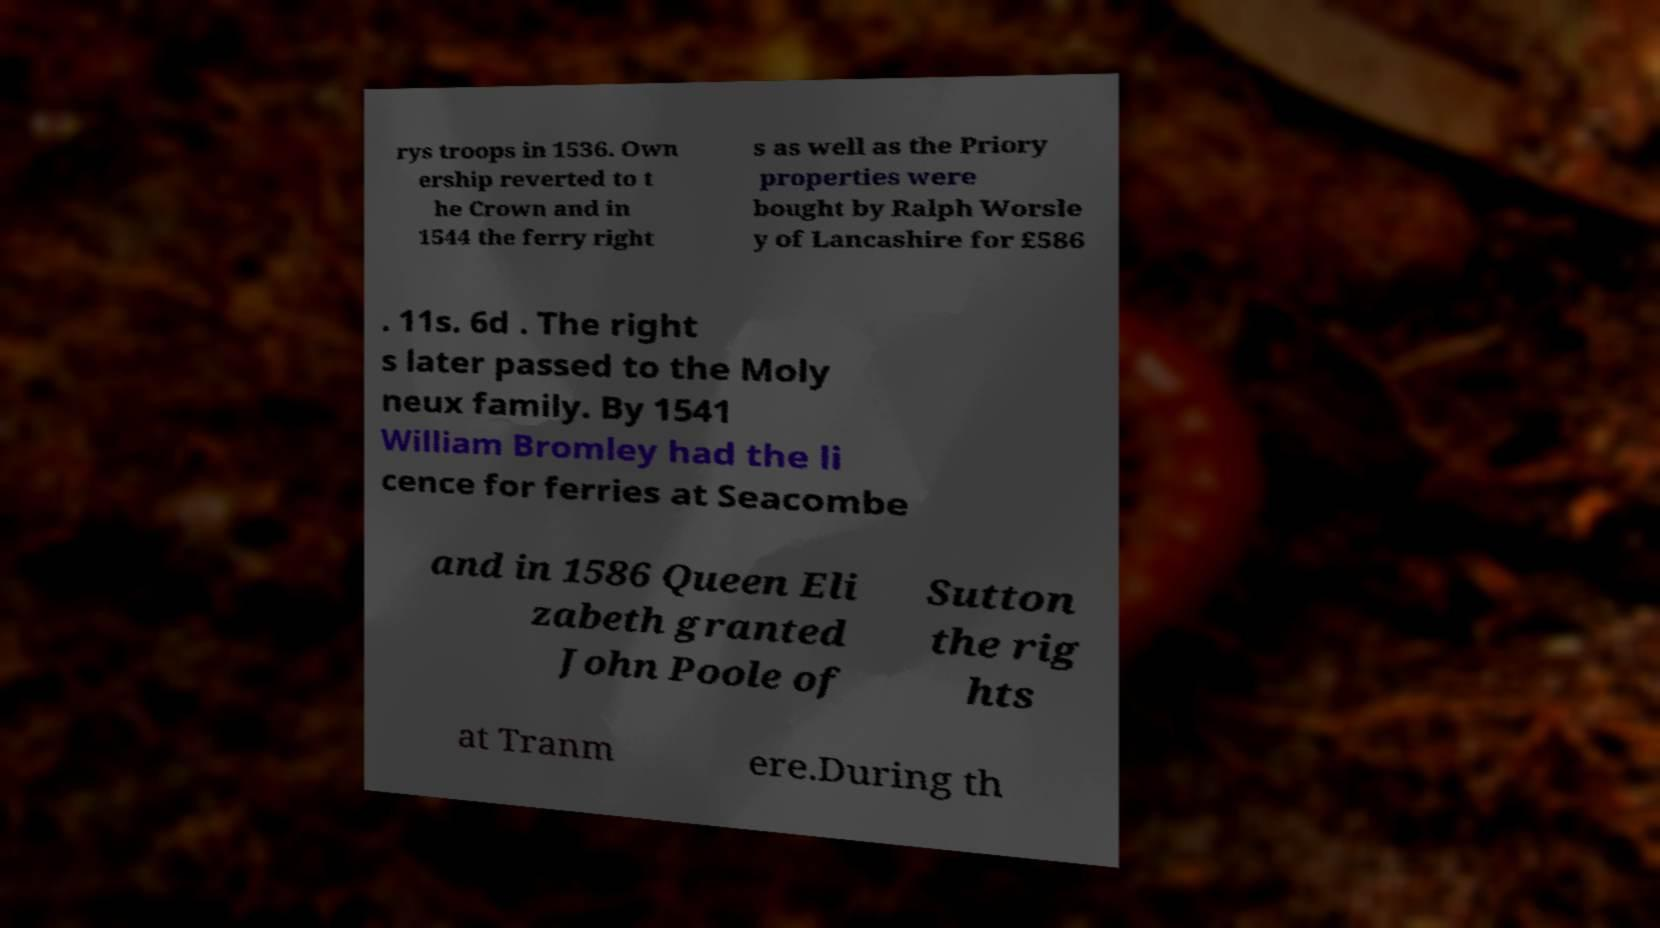Please read and relay the text visible in this image. What does it say? rys troops in 1536. Own ership reverted to t he Crown and in 1544 the ferry right s as well as the Priory properties were bought by Ralph Worsle y of Lancashire for £586 . 11s. 6d . The right s later passed to the Moly neux family. By 1541 William Bromley had the li cence for ferries at Seacombe and in 1586 Queen Eli zabeth granted John Poole of Sutton the rig hts at Tranm ere.During th 